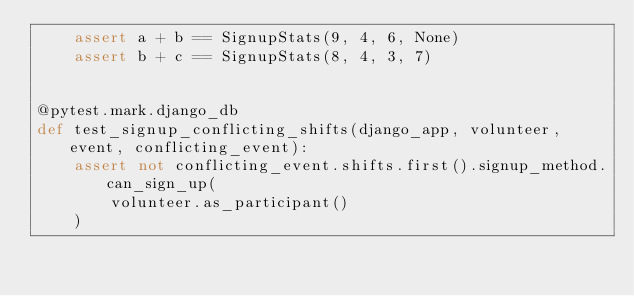<code> <loc_0><loc_0><loc_500><loc_500><_Python_>    assert a + b == SignupStats(9, 4, 6, None)
    assert b + c == SignupStats(8, 4, 3, 7)


@pytest.mark.django_db
def test_signup_conflicting_shifts(django_app, volunteer, event, conflicting_event):
    assert not conflicting_event.shifts.first().signup_method.can_sign_up(
        volunteer.as_participant()
    )
</code> 